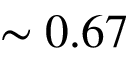<formula> <loc_0><loc_0><loc_500><loc_500>\sim 0 . 6 7</formula> 